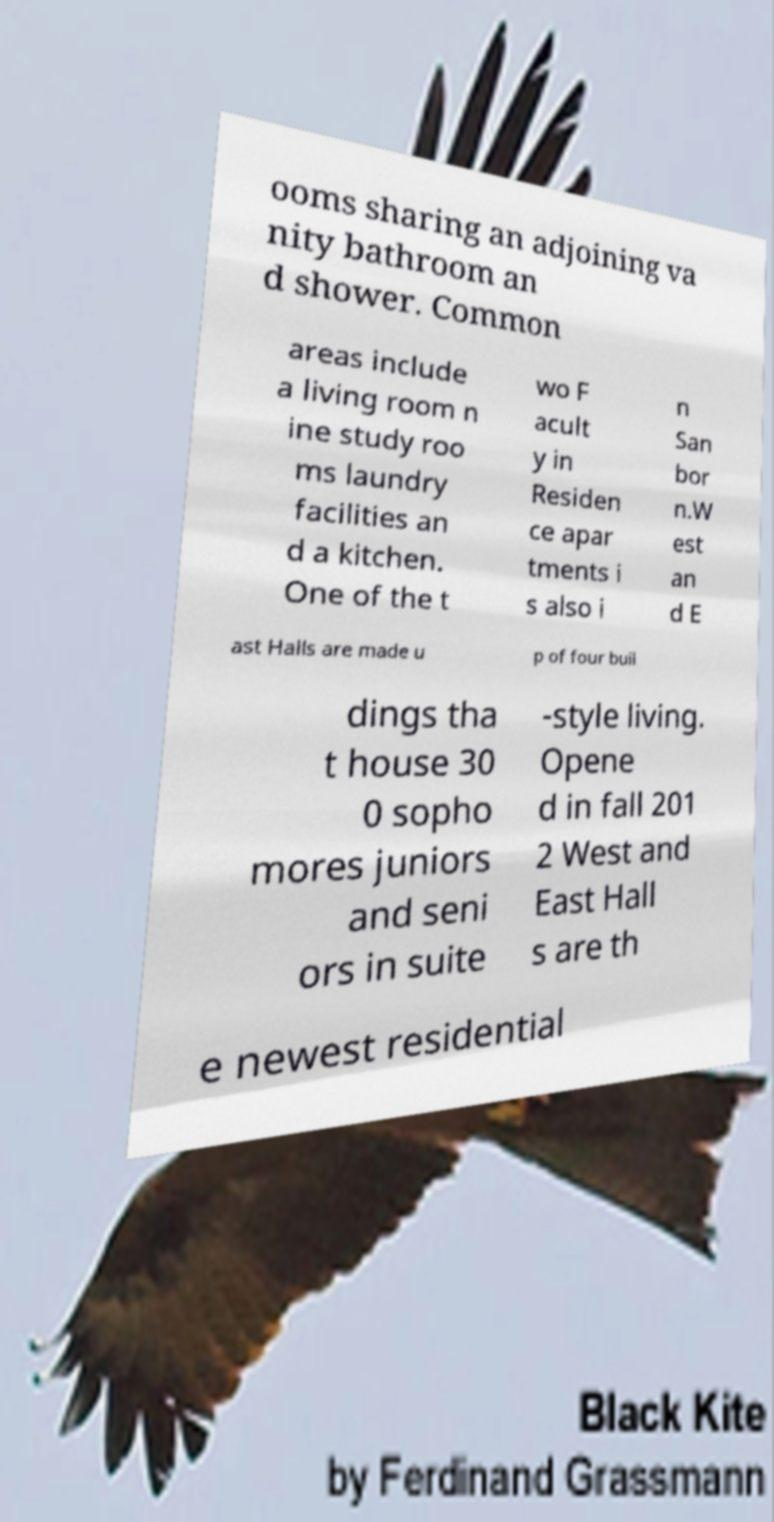Could you extract and type out the text from this image? ooms sharing an adjoining va nity bathroom an d shower. Common areas include a living room n ine study roo ms laundry facilities an d a kitchen. One of the t wo F acult y in Residen ce apar tments i s also i n San bor n.W est an d E ast Halls are made u p of four buil dings tha t house 30 0 sopho mores juniors and seni ors in suite -style living. Opene d in fall 201 2 West and East Hall s are th e newest residential 